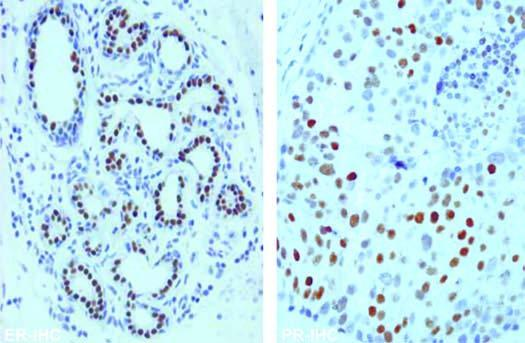do typhoid ulcers in the small intestine show nuclear positivity with er and pr antibody immunostains?
Answer the question using a single word or phrase. No 